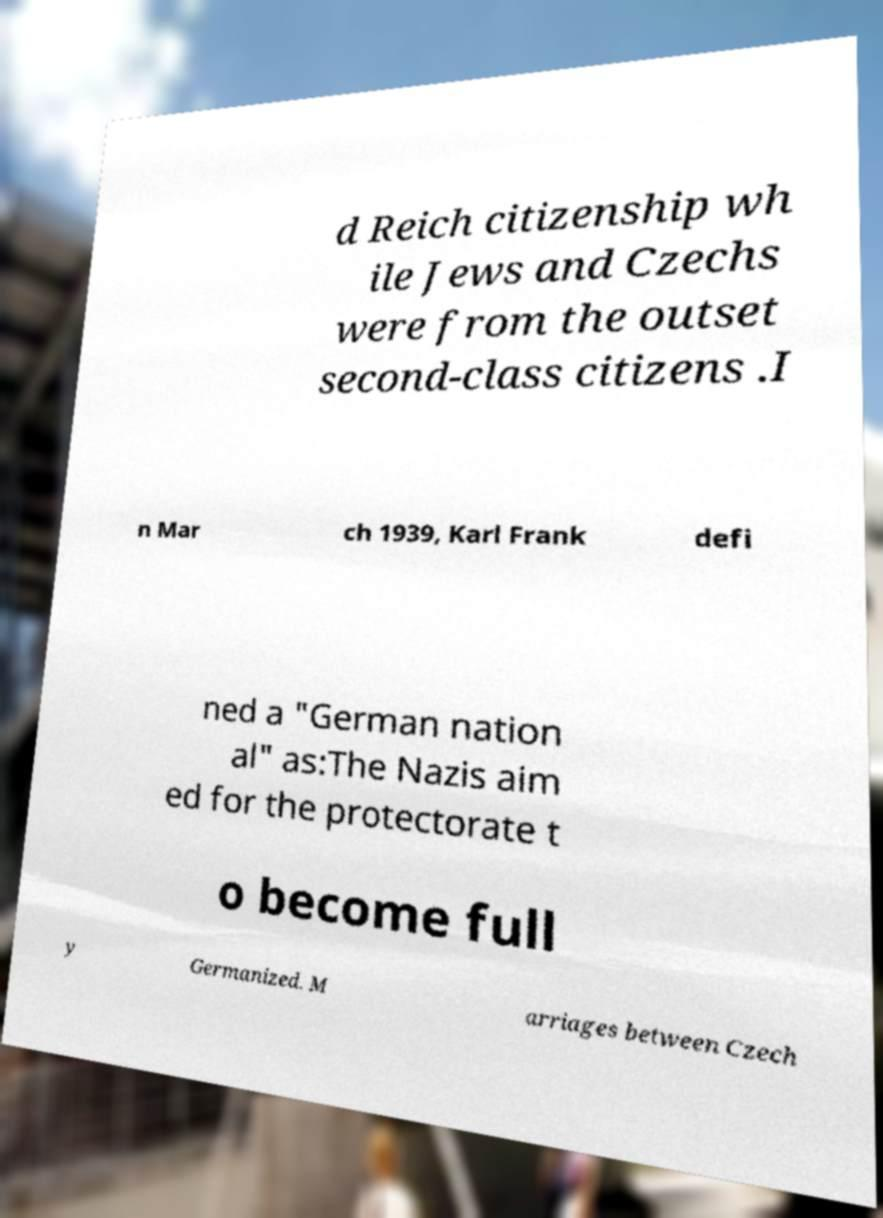Can you read and provide the text displayed in the image?This photo seems to have some interesting text. Can you extract and type it out for me? d Reich citizenship wh ile Jews and Czechs were from the outset second-class citizens .I n Mar ch 1939, Karl Frank defi ned a "German nation al" as:The Nazis aim ed for the protectorate t o become full y Germanized. M arriages between Czech 